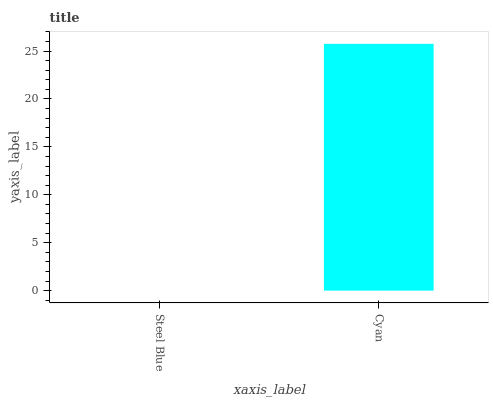Is Steel Blue the minimum?
Answer yes or no. Yes. Is Cyan the maximum?
Answer yes or no. Yes. Is Cyan the minimum?
Answer yes or no. No. Is Cyan greater than Steel Blue?
Answer yes or no. Yes. Is Steel Blue less than Cyan?
Answer yes or no. Yes. Is Steel Blue greater than Cyan?
Answer yes or no. No. Is Cyan less than Steel Blue?
Answer yes or no. No. Is Cyan the high median?
Answer yes or no. Yes. Is Steel Blue the low median?
Answer yes or no. Yes. Is Steel Blue the high median?
Answer yes or no. No. Is Cyan the low median?
Answer yes or no. No. 